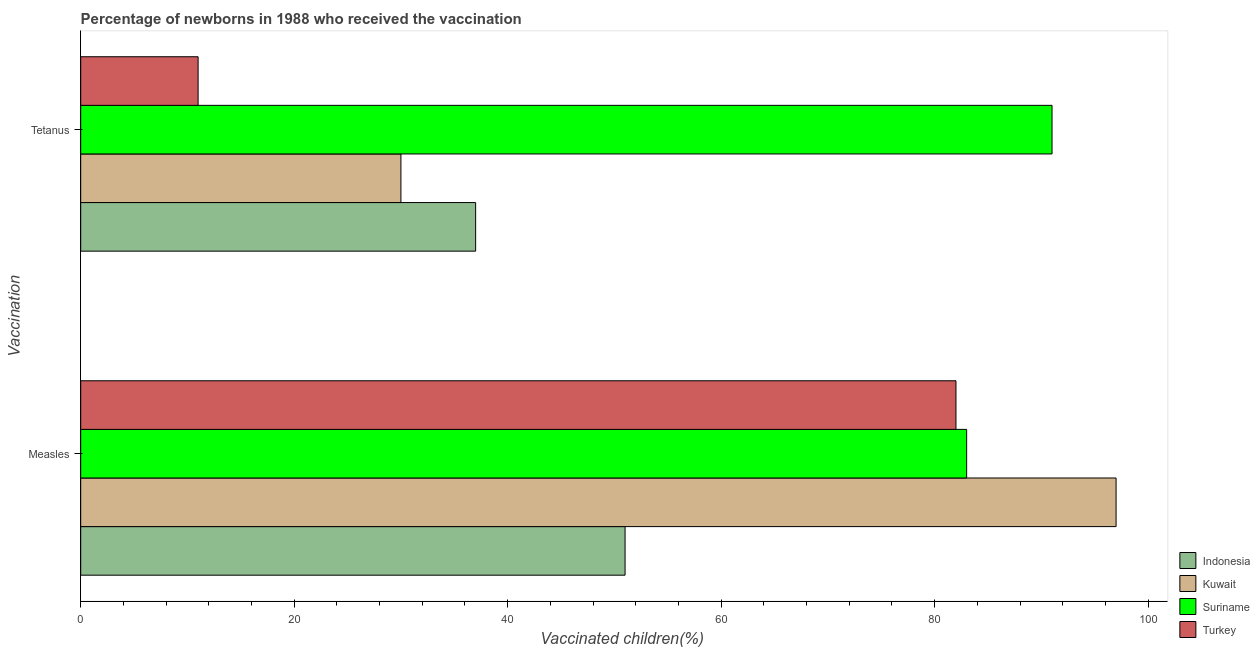How many different coloured bars are there?
Provide a short and direct response. 4. Are the number of bars per tick equal to the number of legend labels?
Provide a short and direct response. Yes. How many bars are there on the 1st tick from the top?
Make the answer very short. 4. How many bars are there on the 2nd tick from the bottom?
Offer a very short reply. 4. What is the label of the 2nd group of bars from the top?
Your answer should be compact. Measles. What is the percentage of newborns who received vaccination for tetanus in Turkey?
Your response must be concise. 11. Across all countries, what is the maximum percentage of newborns who received vaccination for tetanus?
Keep it short and to the point. 91. Across all countries, what is the minimum percentage of newborns who received vaccination for tetanus?
Ensure brevity in your answer.  11. In which country was the percentage of newborns who received vaccination for tetanus maximum?
Make the answer very short. Suriname. In which country was the percentage of newborns who received vaccination for tetanus minimum?
Provide a succinct answer. Turkey. What is the total percentage of newborns who received vaccination for tetanus in the graph?
Provide a succinct answer. 169. What is the difference between the percentage of newborns who received vaccination for measles in Suriname and that in Indonesia?
Keep it short and to the point. 32. What is the difference between the percentage of newborns who received vaccination for tetanus in Turkey and the percentage of newborns who received vaccination for measles in Indonesia?
Give a very brief answer. -40. What is the average percentage of newborns who received vaccination for tetanus per country?
Your answer should be very brief. 42.25. What is the difference between the percentage of newborns who received vaccination for measles and percentage of newborns who received vaccination for tetanus in Suriname?
Make the answer very short. -8. What is the ratio of the percentage of newborns who received vaccination for measles in Turkey to that in Suriname?
Offer a very short reply. 0.99. In how many countries, is the percentage of newborns who received vaccination for measles greater than the average percentage of newborns who received vaccination for measles taken over all countries?
Ensure brevity in your answer.  3. What does the 2nd bar from the top in Tetanus represents?
Keep it short and to the point. Suriname. What does the 4th bar from the bottom in Measles represents?
Your response must be concise. Turkey. How many bars are there?
Your response must be concise. 8. Are all the bars in the graph horizontal?
Your response must be concise. Yes. What is the difference between two consecutive major ticks on the X-axis?
Give a very brief answer. 20. Are the values on the major ticks of X-axis written in scientific E-notation?
Keep it short and to the point. No. Does the graph contain any zero values?
Provide a succinct answer. No. Where does the legend appear in the graph?
Your answer should be compact. Bottom right. How many legend labels are there?
Offer a terse response. 4. How are the legend labels stacked?
Provide a succinct answer. Vertical. What is the title of the graph?
Your response must be concise. Percentage of newborns in 1988 who received the vaccination. What is the label or title of the X-axis?
Provide a short and direct response. Vaccinated children(%)
. What is the label or title of the Y-axis?
Your answer should be very brief. Vaccination. What is the Vaccinated children(%)
 in Indonesia in Measles?
Offer a very short reply. 51. What is the Vaccinated children(%)
 of Kuwait in Measles?
Give a very brief answer. 97. What is the Vaccinated children(%)
 in Suriname in Tetanus?
Provide a succinct answer. 91. What is the Vaccinated children(%)
 in Turkey in Tetanus?
Offer a very short reply. 11. Across all Vaccination, what is the maximum Vaccinated children(%)
 in Kuwait?
Provide a succinct answer. 97. Across all Vaccination, what is the maximum Vaccinated children(%)
 of Suriname?
Ensure brevity in your answer.  91. Across all Vaccination, what is the maximum Vaccinated children(%)
 in Turkey?
Your answer should be compact. 82. Across all Vaccination, what is the minimum Vaccinated children(%)
 in Indonesia?
Your answer should be compact. 37. Across all Vaccination, what is the minimum Vaccinated children(%)
 of Kuwait?
Your answer should be compact. 30. Across all Vaccination, what is the minimum Vaccinated children(%)
 of Suriname?
Provide a short and direct response. 83. What is the total Vaccinated children(%)
 in Kuwait in the graph?
Offer a very short reply. 127. What is the total Vaccinated children(%)
 in Suriname in the graph?
Make the answer very short. 174. What is the total Vaccinated children(%)
 of Turkey in the graph?
Keep it short and to the point. 93. What is the difference between the Vaccinated children(%)
 in Indonesia in Measles and that in Tetanus?
Make the answer very short. 14. What is the difference between the Vaccinated children(%)
 of Kuwait in Measles and that in Tetanus?
Your answer should be very brief. 67. What is the difference between the Vaccinated children(%)
 in Suriname in Measles and that in Tetanus?
Ensure brevity in your answer.  -8. What is the difference between the Vaccinated children(%)
 of Indonesia in Measles and the Vaccinated children(%)
 of Kuwait in Tetanus?
Your answer should be very brief. 21. What is the difference between the Vaccinated children(%)
 in Indonesia in Measles and the Vaccinated children(%)
 in Suriname in Tetanus?
Your answer should be compact. -40. What is the difference between the Vaccinated children(%)
 of Indonesia in Measles and the Vaccinated children(%)
 of Turkey in Tetanus?
Offer a very short reply. 40. What is the difference between the Vaccinated children(%)
 of Kuwait in Measles and the Vaccinated children(%)
 of Turkey in Tetanus?
Keep it short and to the point. 86. What is the average Vaccinated children(%)
 of Kuwait per Vaccination?
Offer a very short reply. 63.5. What is the average Vaccinated children(%)
 in Suriname per Vaccination?
Your response must be concise. 87. What is the average Vaccinated children(%)
 of Turkey per Vaccination?
Provide a succinct answer. 46.5. What is the difference between the Vaccinated children(%)
 in Indonesia and Vaccinated children(%)
 in Kuwait in Measles?
Provide a succinct answer. -46. What is the difference between the Vaccinated children(%)
 in Indonesia and Vaccinated children(%)
 in Suriname in Measles?
Provide a succinct answer. -32. What is the difference between the Vaccinated children(%)
 in Indonesia and Vaccinated children(%)
 in Turkey in Measles?
Give a very brief answer. -31. What is the difference between the Vaccinated children(%)
 in Kuwait and Vaccinated children(%)
 in Suriname in Measles?
Your response must be concise. 14. What is the difference between the Vaccinated children(%)
 in Indonesia and Vaccinated children(%)
 in Suriname in Tetanus?
Keep it short and to the point. -54. What is the difference between the Vaccinated children(%)
 in Kuwait and Vaccinated children(%)
 in Suriname in Tetanus?
Offer a very short reply. -61. What is the ratio of the Vaccinated children(%)
 in Indonesia in Measles to that in Tetanus?
Provide a succinct answer. 1.38. What is the ratio of the Vaccinated children(%)
 in Kuwait in Measles to that in Tetanus?
Ensure brevity in your answer.  3.23. What is the ratio of the Vaccinated children(%)
 in Suriname in Measles to that in Tetanus?
Make the answer very short. 0.91. What is the ratio of the Vaccinated children(%)
 of Turkey in Measles to that in Tetanus?
Your answer should be very brief. 7.45. What is the difference between the highest and the second highest Vaccinated children(%)
 of Turkey?
Your answer should be compact. 71. What is the difference between the highest and the lowest Vaccinated children(%)
 in Indonesia?
Provide a succinct answer. 14. What is the difference between the highest and the lowest Vaccinated children(%)
 in Suriname?
Your answer should be compact. 8. What is the difference between the highest and the lowest Vaccinated children(%)
 in Turkey?
Your answer should be very brief. 71. 